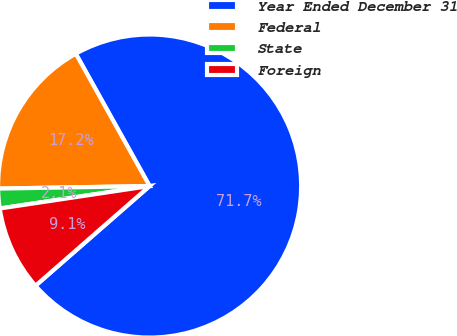Convert chart to OTSL. <chart><loc_0><loc_0><loc_500><loc_500><pie_chart><fcel>Year Ended December 31<fcel>Federal<fcel>State<fcel>Foreign<nl><fcel>71.68%<fcel>17.17%<fcel>2.1%<fcel>9.06%<nl></chart> 